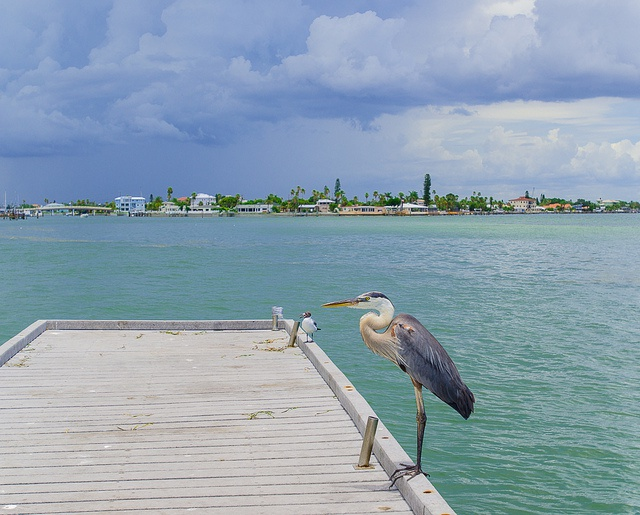Describe the objects in this image and their specific colors. I can see bird in darkgray, gray, black, and teal tones and bird in darkgray, lightgray, and gray tones in this image. 